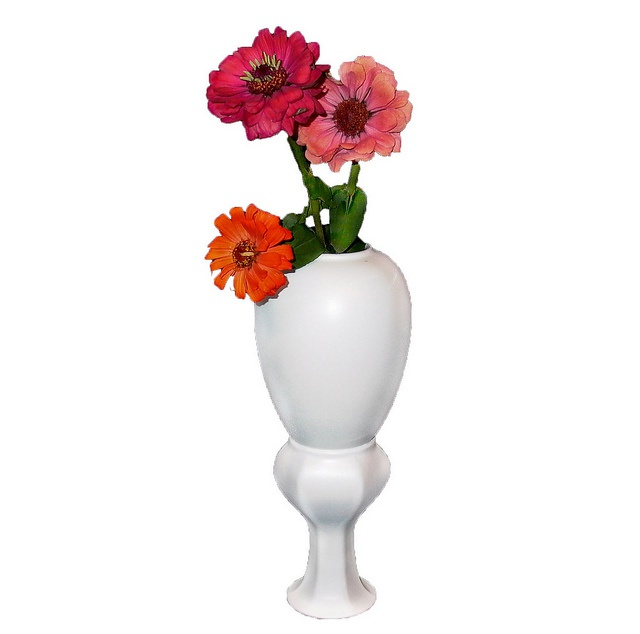Describe the objects in this image and their specific colors. I can see a vase in white, lightgray, and darkgray tones in this image. 